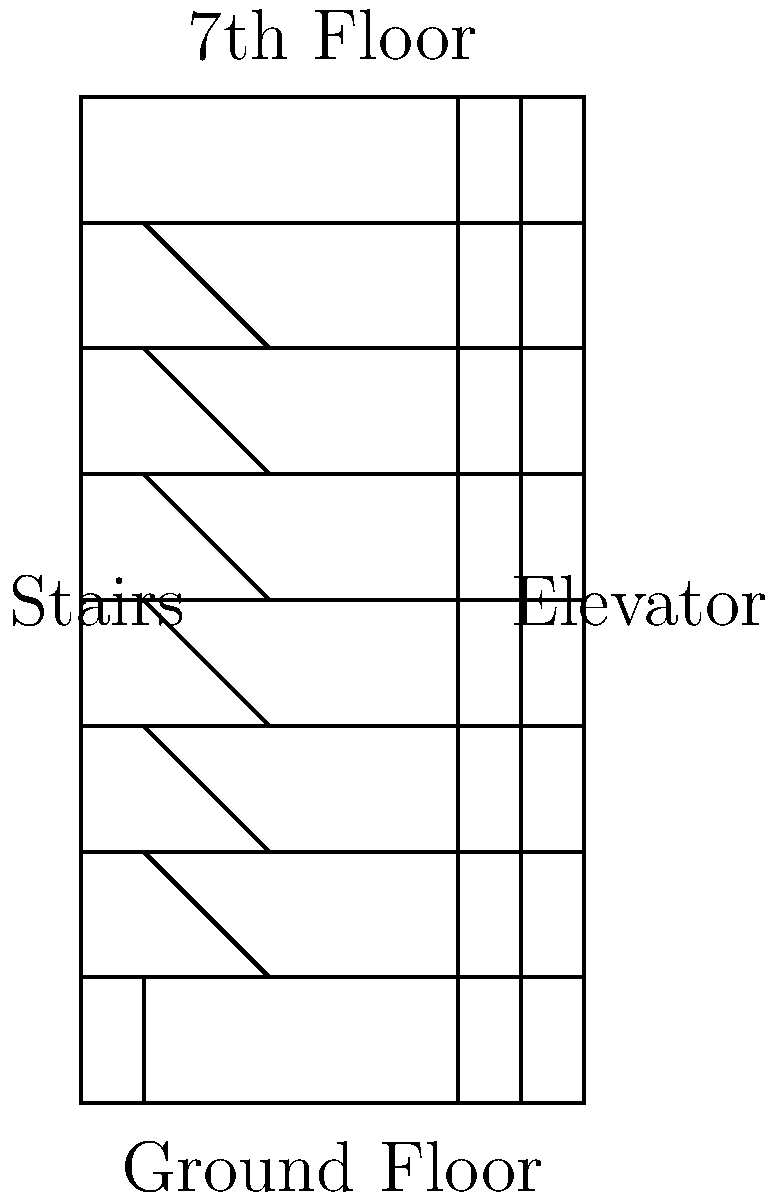A middle-aged man needs to reach his office on the 7th floor of a building. The building is 28 meters tall, and each floor is 4 meters high. If he takes the stairs, he will exert a force of 800 N at an angle of 30° to the horizontal. If he takes the elevator, it consumes 5 kWh of electrical energy for the entire trip. Which option requires less work to be done, and by how much? Let's break this down step-by-step:

1) First, let's calculate the work done when taking the stairs:
   - The vertical distance is 28 meters (7 floors × 4 meters/floor)
   - The force exerted is 800 N at 30° to the horizontal
   - The vertical component of this force is: $800 \sin(30°) = 400$ N
   - Work done = Force × Distance = $400 \text{ N} \times 28 \text{ m} = 11,200 \text{ J}$

2) Now, let's convert the elevator's energy consumption to Joules:
   - 5 kWh = 5 × 3,600,000 J = 18,000,000 J

3) Comparing the two:
   - Stairs: 11,200 J
   - Elevator: 18,000,000 J

4) The difference is:
   18,000,000 J - 11,200 J = 17,988,800 J

Therefore, taking the stairs requires less work, by 17,988,800 J or approximately 17.99 MJ.
Answer: Stairs; 17.99 MJ less 